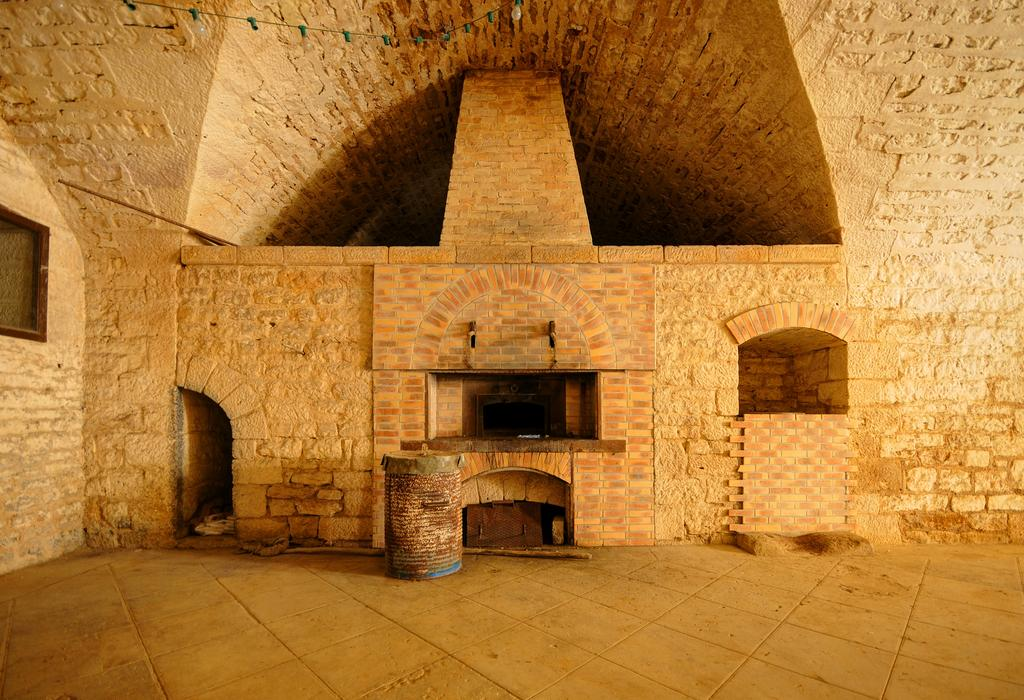What is the main subject of the image? The main subject of the image is a building. Are there any specific features visible in the image? Yes, there are lights visible in the image. What object can be seen in the image besides the building? There is a drum in the image. Can you describe the structure of the building? The building has a floor at the bottom. How does the building contribute to pollution in the image? There is no information about pollution in the image, and the building itself does not emit any pollutants. What type of pot is being used to play the drum in the image? There is no pot present in the image; only a drum is visible. 